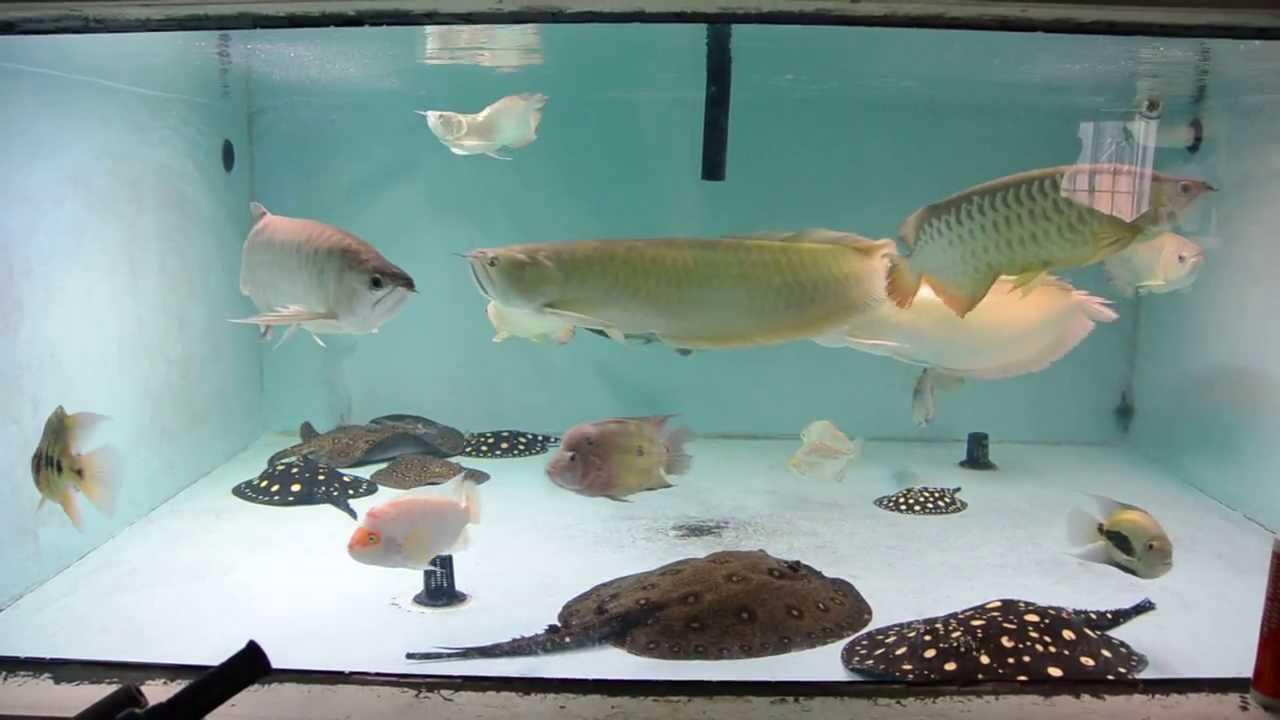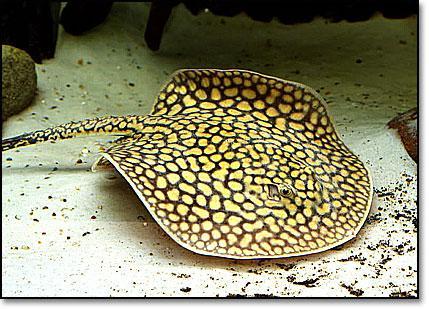The first image is the image on the left, the second image is the image on the right. Examine the images to the left and right. Is the description "There are exactly three stingrays." accurate? Answer yes or no. No. 